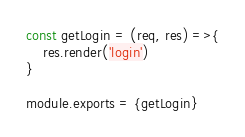<code> <loc_0><loc_0><loc_500><loc_500><_JavaScript_>const getLogin = (req, res) =>{
    res.render('login')
}

module.exports = {getLogin}</code> 